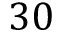Convert formula to latex. <formula><loc_0><loc_0><loc_500><loc_500>3 0</formula> 